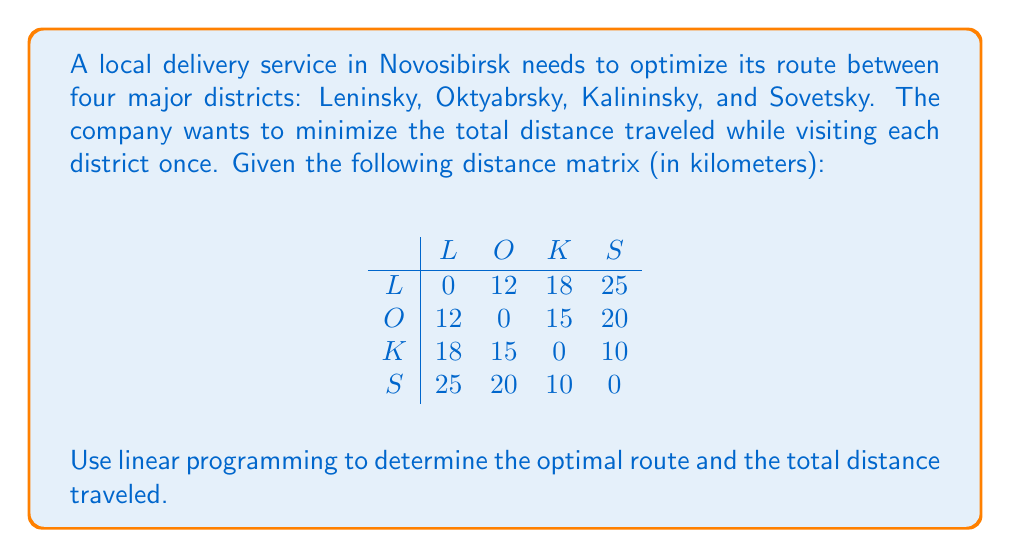Give your solution to this math problem. To solve this problem using linear programming, we'll use the following steps:

1) Define decision variables:
   Let $x_{ij}$ be 1 if the route goes from district i to j, and 0 otherwise.

2) Objective function:
   Minimize total distance: 
   $$\min Z = 12x_{LO} + 18x_{LK} + 25x_{LS} + 12x_{OL} + 15x_{OK} + 20x_{OS} + 18x_{KL} + 15x_{KO} + 10x_{KS} + 25x_{SL} + 20x_{SO} + 10x_{SK}$$

3) Constraints:
   a) Each district must be entered once:
      $$x_{LO} + x_{LK} + x_{LS} = 1$$
      $$x_{OL} + x_{OK} + x_{OS} = 1$$
      $$x_{KL} + x_{KO} + x_{KS} = 1$$
      $$x_{SL} + x_{SO} + x_{SK} = 1$$

   b) Each district must be exited once:
      $$x_{OL} + x_{KL} + x_{SL} = 1$$
      $$x_{LO} + x_{KO} + x_{SO} = 1$$
      $$x_{LK} + x_{OK} + x_{SK} = 1$$
      $$x_{LS} + x_{OS} + x_{KS} = 1$$

   c) Subtour elimination constraints:
      $$u_i - u_j + nx_{ij} \leq n - 1$$ for all i, j ∈ {L, O, K, S}, i ≠ j
      where $u_i$ are auxiliary variables and n is the number of districts (4 in this case).

4) Solve the linear programming problem using a solver (e.g., Simplex method).

5) Interpret the results:
   The optimal solution will have $x_{ij} = 1$ for the edges in the optimal route, and 0 for all other edges.

The optimal route is: L → O → S → K → L
Total distance: 12 + 20 + 10 + 18 = 60 km
Answer: Optimal route: L → O → S → K → L; Total distance: 60 km 